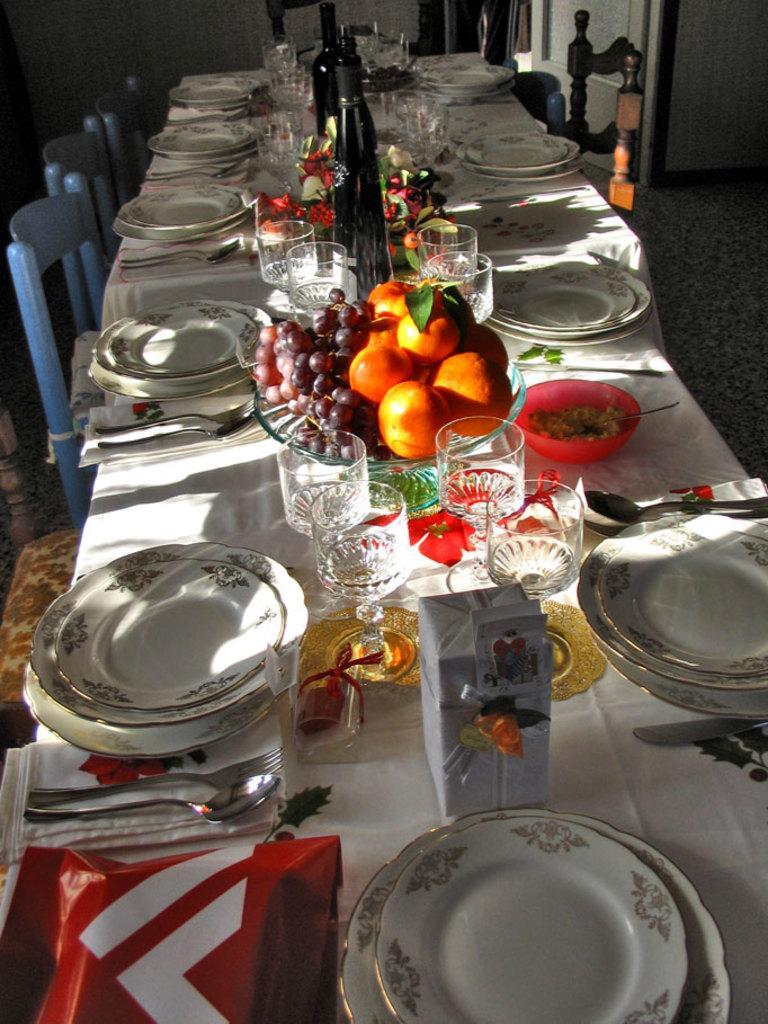In one or two sentences, can you explain what this image depicts? There are plate, glasses and fruits on these dining tables. There are chairs in the left side of an image. 